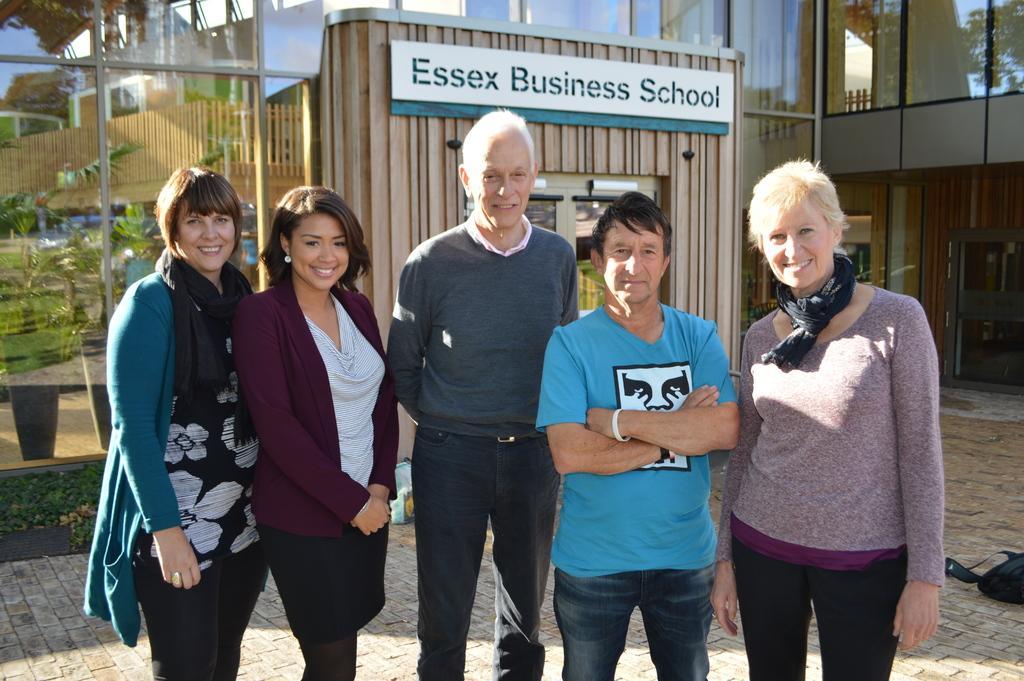How would you summarize this image in a sentence or two? In the picture we can see three women and two men are standing together and smiling and behind them, we can see the part of the building wall with glass door and on the top of it, we can see the board mentioned with a name Essex business school and beside it we can see the glass walls. 